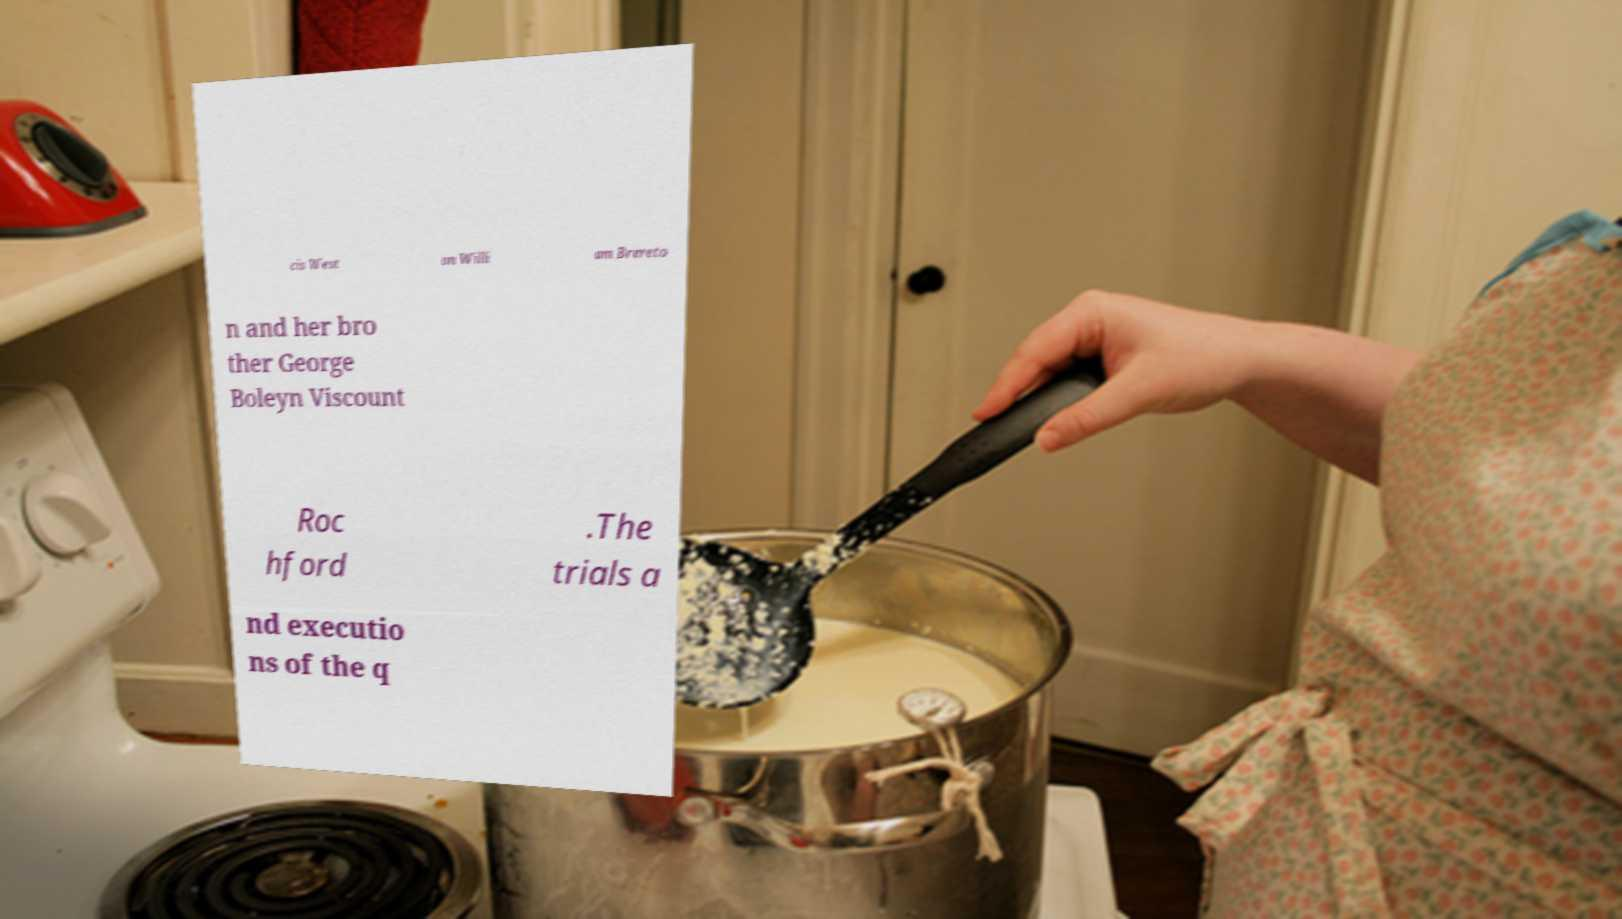Please read and relay the text visible in this image. What does it say? cis West on Willi am Brereto n and her bro ther George Boleyn Viscount Roc hford .The trials a nd executio ns of the q 